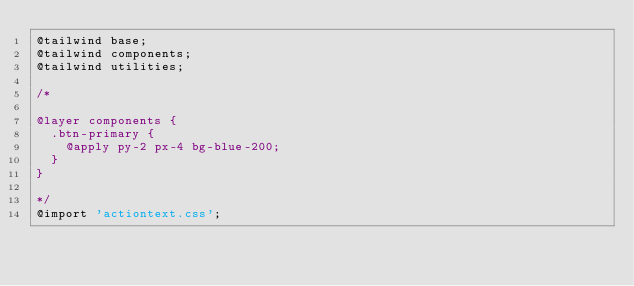Convert code to text. <code><loc_0><loc_0><loc_500><loc_500><_CSS_>@tailwind base;
@tailwind components;
@tailwind utilities;

/*

@layer components {
  .btn-primary {
    @apply py-2 px-4 bg-blue-200;
  }
}

*/
@import 'actiontext.css';</code> 